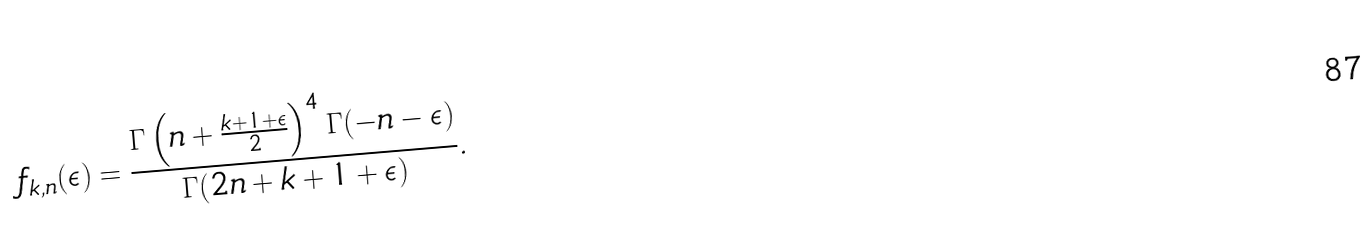Convert formula to latex. <formula><loc_0><loc_0><loc_500><loc_500>f _ { k , n } ( \epsilon ) = \frac { \Gamma \left ( n + \frac { k + 1 + \epsilon } { 2 } \right ) ^ { 4 } \Gamma ( - n - \epsilon ) } { \Gamma ( 2 n + k + 1 + \epsilon ) } .</formula> 